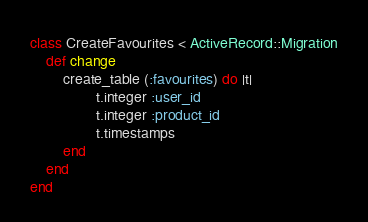<code> <loc_0><loc_0><loc_500><loc_500><_Ruby_>class CreateFavourites < ActiveRecord::Migration
	def change
		create_table (:favourites) do |t|
				t.integer :user_id
				t.integer :product_id
				t.timestamps
		end
	end
end
</code> 